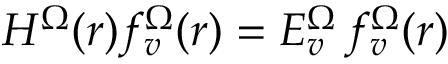<formula> <loc_0><loc_0><loc_500><loc_500>\begin{array} { r } { H ^ { \Omega } ( r ) f _ { v } ^ { \Omega } ( r ) = E _ { v } ^ { \Omega } \, f _ { v } ^ { \Omega } ( r ) } \end{array}</formula> 